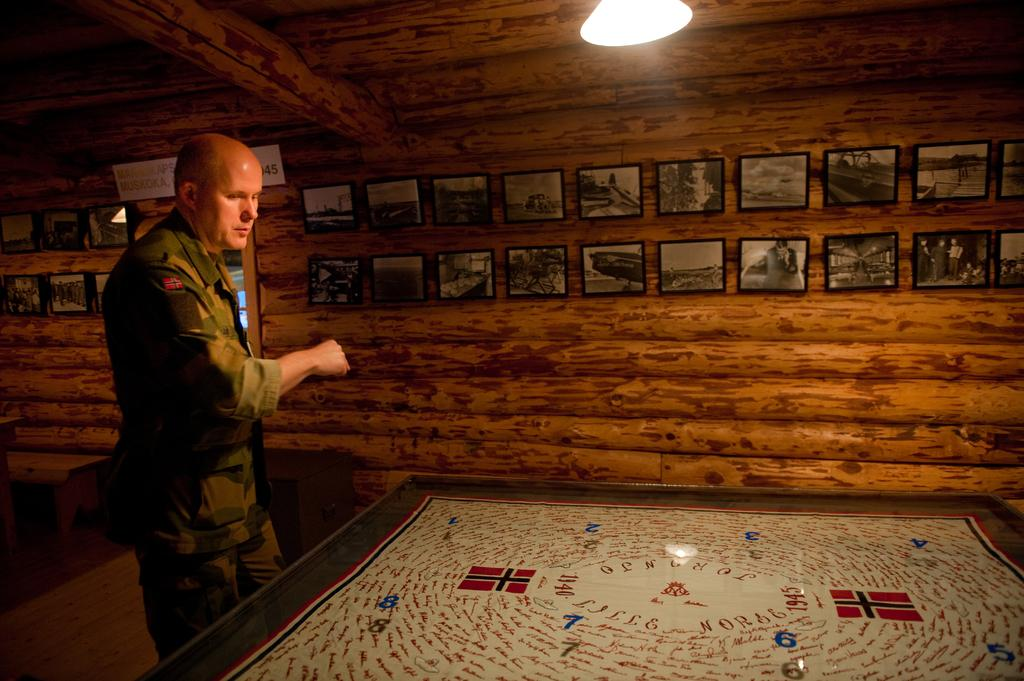What is the person in the image doing? The person is standing in front of a table. What can be seen on the wall behind the person? There are frames on a wooden wall at the back side. Can you describe the lighting in the image? There is a light at the top of the image. How many spiders are crawling on the stick in the image? There are no spiders or sticks present in the image. 